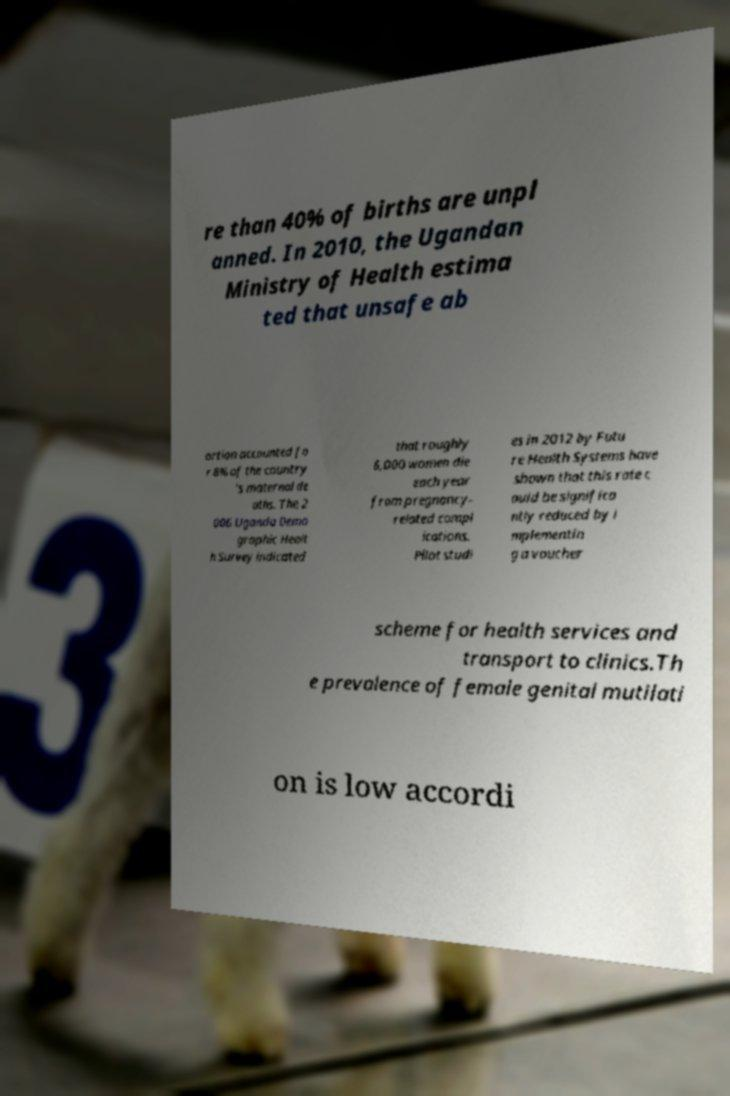I need the written content from this picture converted into text. Can you do that? re than 40% of births are unpl anned. In 2010, the Ugandan Ministry of Health estima ted that unsafe ab ortion accounted fo r 8% of the country 's maternal de aths. The 2 006 Uganda Demo graphic Healt h Survey indicated that roughly 6,000 women die each year from pregnancy- related compl ications. Pilot studi es in 2012 by Futu re Health Systems have shown that this rate c ould be significa ntly reduced by i mplementin g a voucher scheme for health services and transport to clinics.Th e prevalence of female genital mutilati on is low accordi 